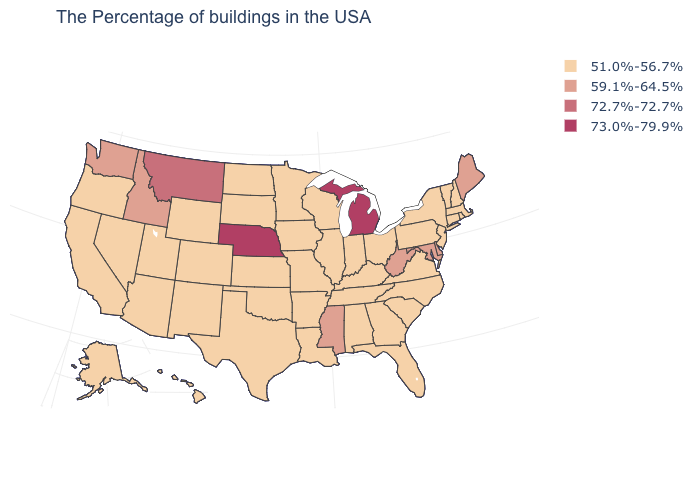Which states have the lowest value in the USA?
Answer briefly. Massachusetts, Rhode Island, New Hampshire, Vermont, Connecticut, New York, New Jersey, Pennsylvania, Virginia, North Carolina, South Carolina, Ohio, Florida, Georgia, Kentucky, Indiana, Alabama, Tennessee, Wisconsin, Illinois, Louisiana, Missouri, Arkansas, Minnesota, Iowa, Kansas, Oklahoma, Texas, South Dakota, North Dakota, Wyoming, Colorado, New Mexico, Utah, Arizona, Nevada, California, Oregon, Alaska, Hawaii. Does Connecticut have a lower value than Indiana?
Be succinct. No. Is the legend a continuous bar?
Be succinct. No. Name the states that have a value in the range 59.1%-64.5%?
Write a very short answer. Maine, Delaware, Maryland, West Virginia, Mississippi, Idaho, Washington. Name the states that have a value in the range 73.0%-79.9%?
Be succinct. Michigan, Nebraska. Does Kentucky have a lower value than Minnesota?
Answer briefly. No. Name the states that have a value in the range 72.7%-72.7%?
Keep it brief. Montana. What is the highest value in the South ?
Answer briefly. 59.1%-64.5%. Which states have the highest value in the USA?
Short answer required. Michigan, Nebraska. Which states have the lowest value in the USA?
Give a very brief answer. Massachusetts, Rhode Island, New Hampshire, Vermont, Connecticut, New York, New Jersey, Pennsylvania, Virginia, North Carolina, South Carolina, Ohio, Florida, Georgia, Kentucky, Indiana, Alabama, Tennessee, Wisconsin, Illinois, Louisiana, Missouri, Arkansas, Minnesota, Iowa, Kansas, Oklahoma, Texas, South Dakota, North Dakota, Wyoming, Colorado, New Mexico, Utah, Arizona, Nevada, California, Oregon, Alaska, Hawaii. Among the states that border Nevada , which have the highest value?
Write a very short answer. Idaho. What is the value of Tennessee?
Quick response, please. 51.0%-56.7%. Name the states that have a value in the range 51.0%-56.7%?
Short answer required. Massachusetts, Rhode Island, New Hampshire, Vermont, Connecticut, New York, New Jersey, Pennsylvania, Virginia, North Carolina, South Carolina, Ohio, Florida, Georgia, Kentucky, Indiana, Alabama, Tennessee, Wisconsin, Illinois, Louisiana, Missouri, Arkansas, Minnesota, Iowa, Kansas, Oklahoma, Texas, South Dakota, North Dakota, Wyoming, Colorado, New Mexico, Utah, Arizona, Nevada, California, Oregon, Alaska, Hawaii. Which states have the highest value in the USA?
Concise answer only. Michigan, Nebraska. 